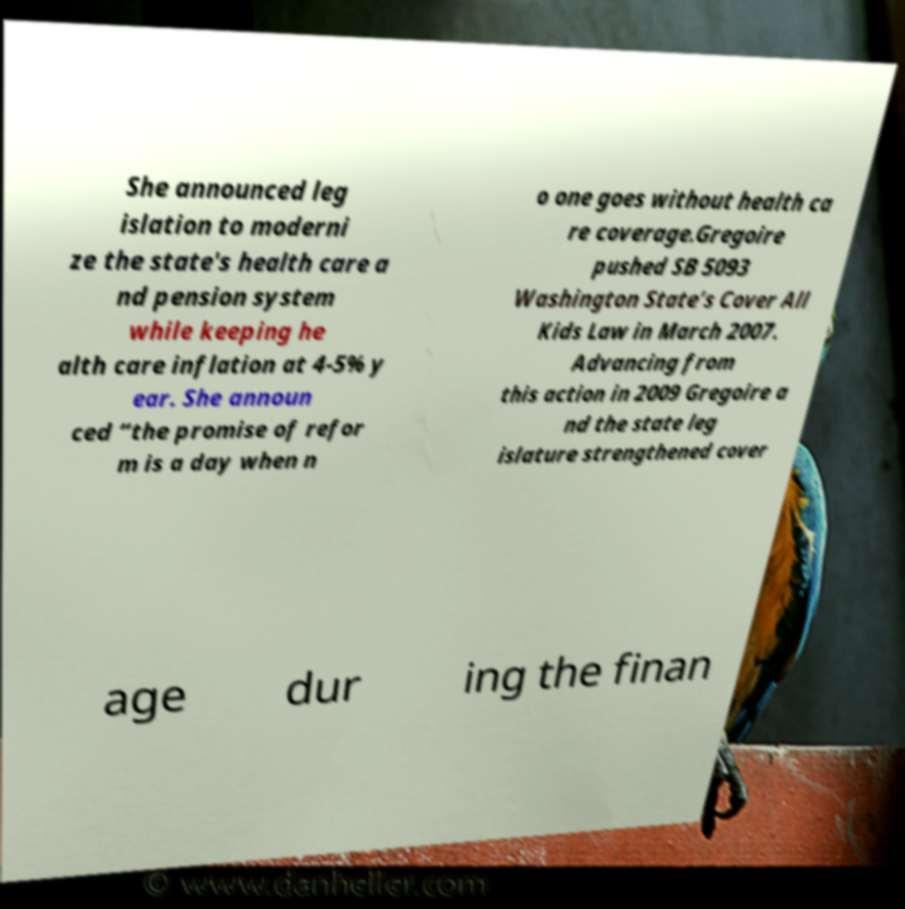Could you assist in decoding the text presented in this image and type it out clearly? She announced leg islation to moderni ze the state's health care a nd pension system while keeping he alth care inflation at 4-5% y ear. She announ ced “the promise of refor m is a day when n o one goes without health ca re coverage.Gregoire pushed SB 5093 Washington State’s Cover All Kids Law in March 2007. Advancing from this action in 2009 Gregoire a nd the state leg islature strengthened cover age dur ing the finan 